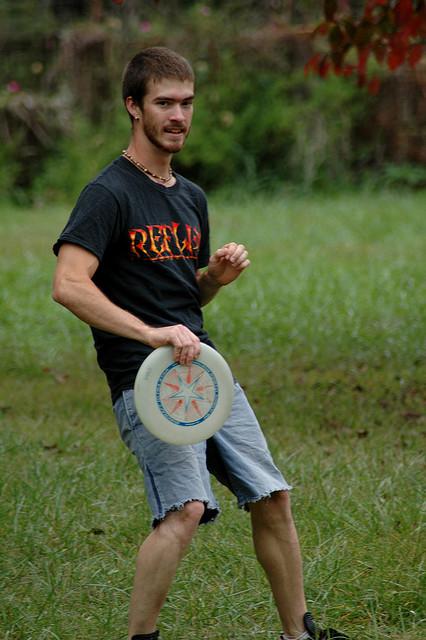Is there writing on the shirt?
Answer briefly. Yes. Are the adult feet the feet of moms?
Give a very brief answer. No. Are his fists clenched?
Write a very short answer. Yes. Is this man wearing jewelry?
Keep it brief. Yes. Does the man appear to have a mole on his neck?
Concise answer only. No. What is this person holding?
Give a very brief answer. Frisbee. 